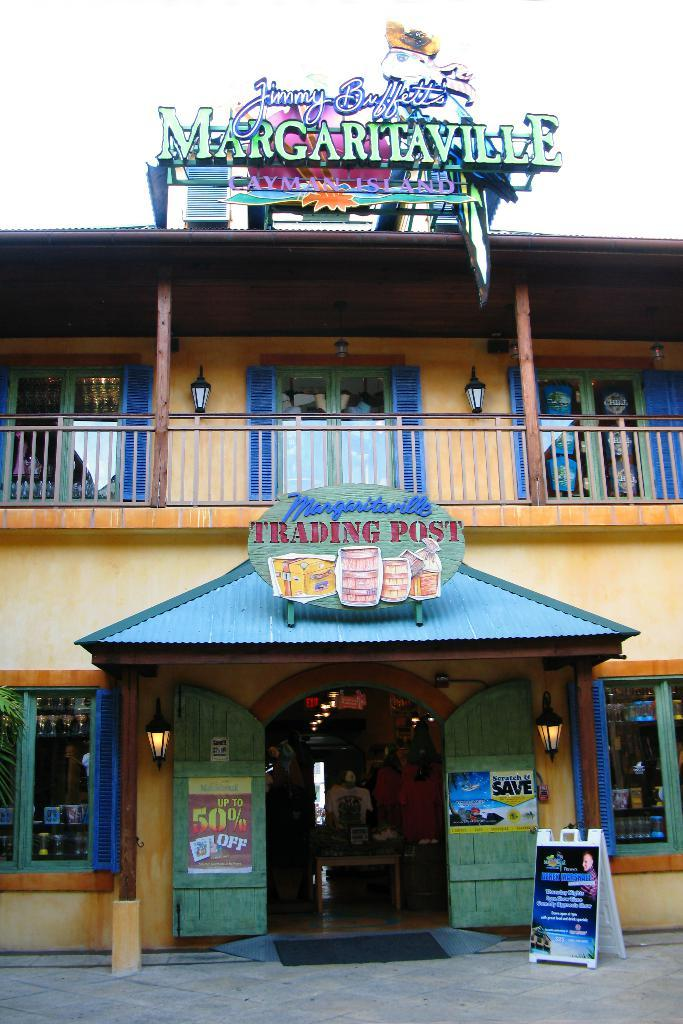<image>
Render a clear and concise summary of the photo. A Jimmy Buffet's Margaritaville Trading Post store with a 50% off sign on the door. 